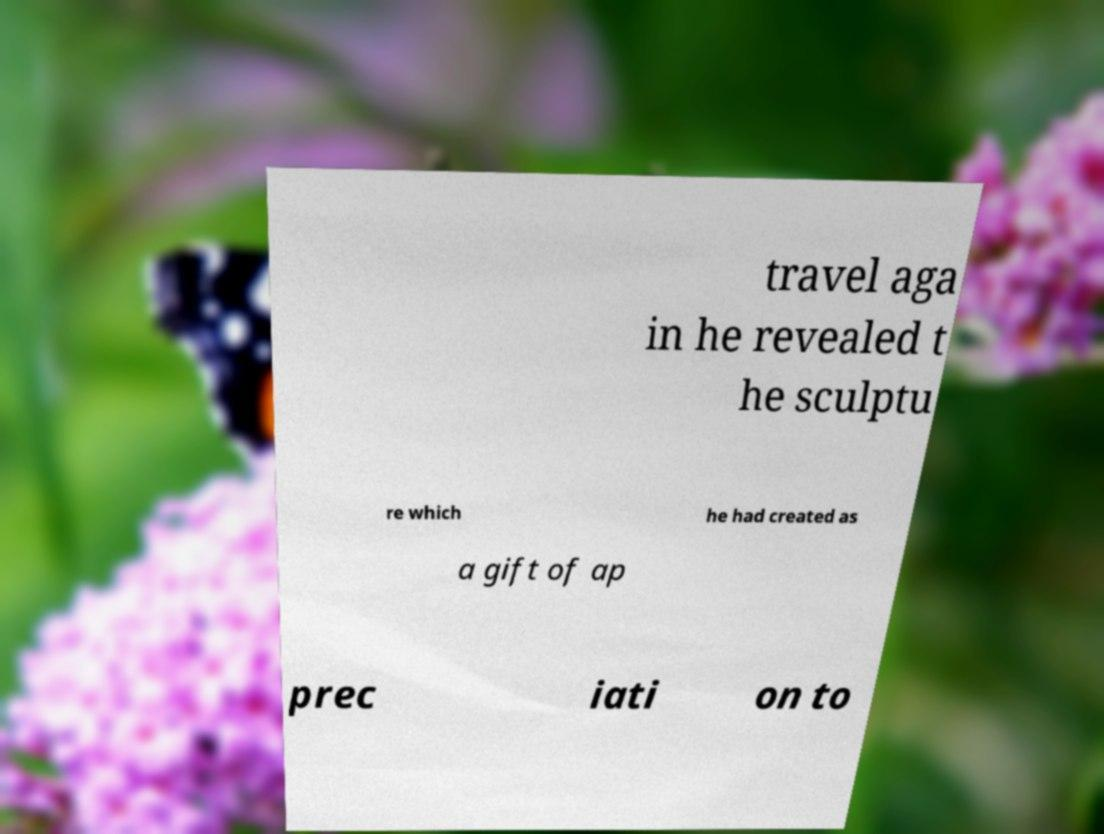Please read and relay the text visible in this image. What does it say? travel aga in he revealed t he sculptu re which he had created as a gift of ap prec iati on to 